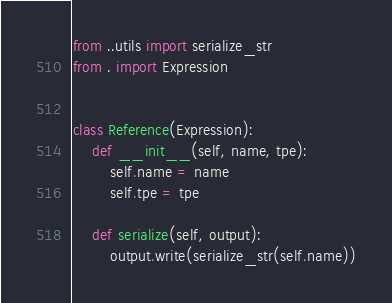<code> <loc_0><loc_0><loc_500><loc_500><_Python_>from ..utils import serialize_str
from . import Expression


class Reference(Expression):
    def __init__(self, name, tpe):
        self.name = name
        self.tpe = tpe

    def serialize(self, output):
        output.write(serialize_str(self.name))
</code> 